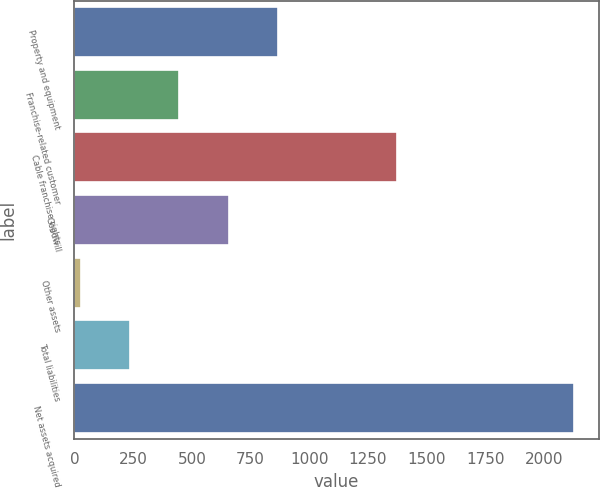Convert chart. <chart><loc_0><loc_0><loc_500><loc_500><bar_chart><fcel>Property and equipment<fcel>Franchise-related customer<fcel>Cable franchise rights<fcel>Goodwill<fcel>Other assets<fcel>Total liabilities<fcel>Net assets acquired<nl><fcel>866.6<fcel>446.8<fcel>1374<fcel>656.7<fcel>27<fcel>236.9<fcel>2126<nl></chart> 